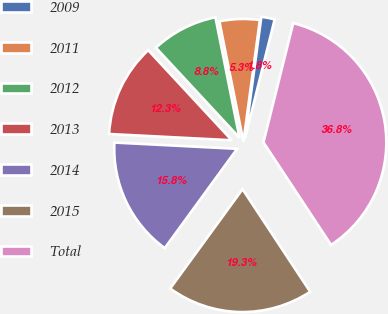<chart> <loc_0><loc_0><loc_500><loc_500><pie_chart><fcel>2009<fcel>2011<fcel>2012<fcel>2013<fcel>2014<fcel>2015<fcel>Total<nl><fcel>1.76%<fcel>5.27%<fcel>8.77%<fcel>12.28%<fcel>15.79%<fcel>19.3%<fcel>36.83%<nl></chart> 